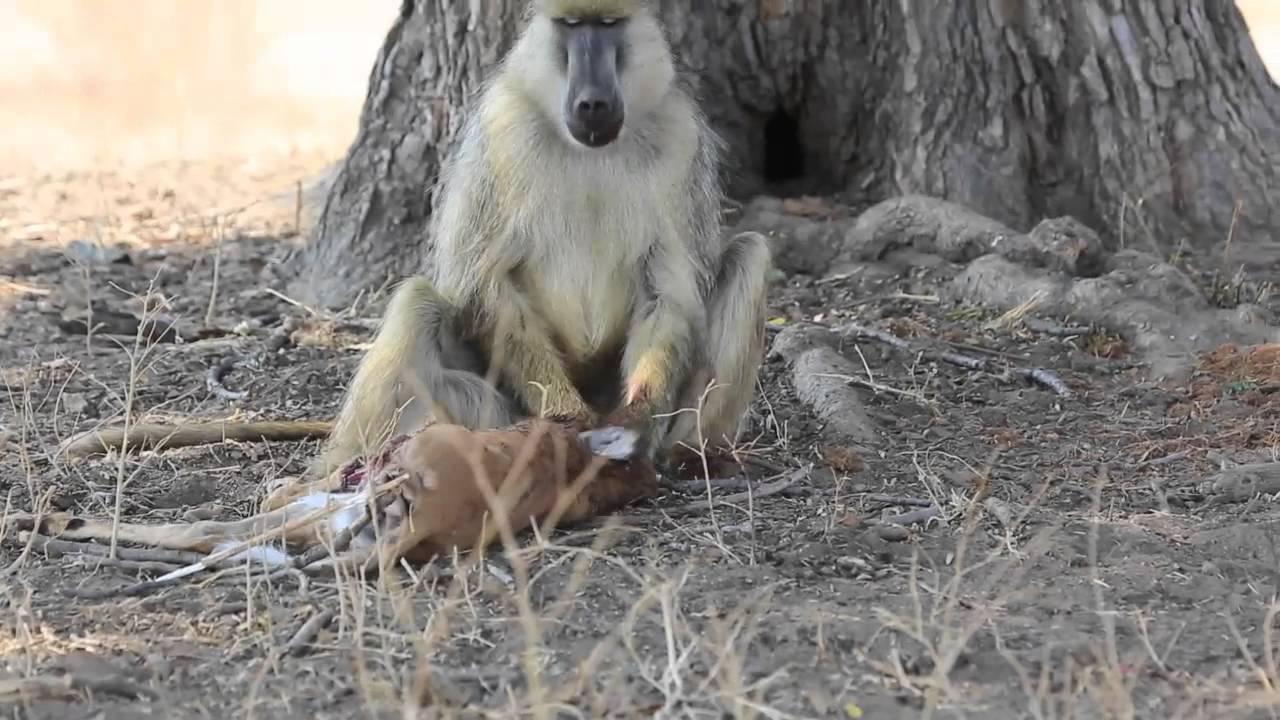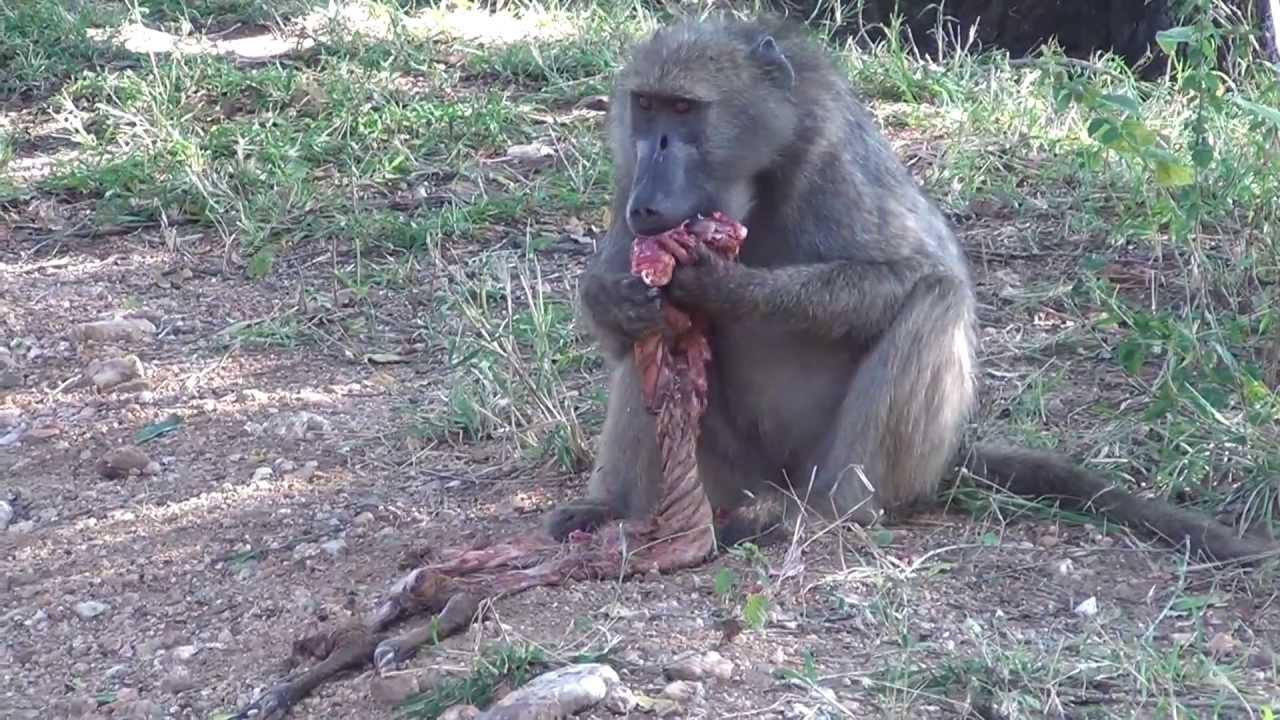The first image is the image on the left, the second image is the image on the right. For the images displayed, is the sentence "The image on the left contains no less than two baboons sitting in a grassy field." factually correct? Answer yes or no. No. The first image is the image on the left, the second image is the image on the right. Assess this claim about the two images: "There are exactly two baboons in at least one of the images.". Correct or not? Answer yes or no. No. 